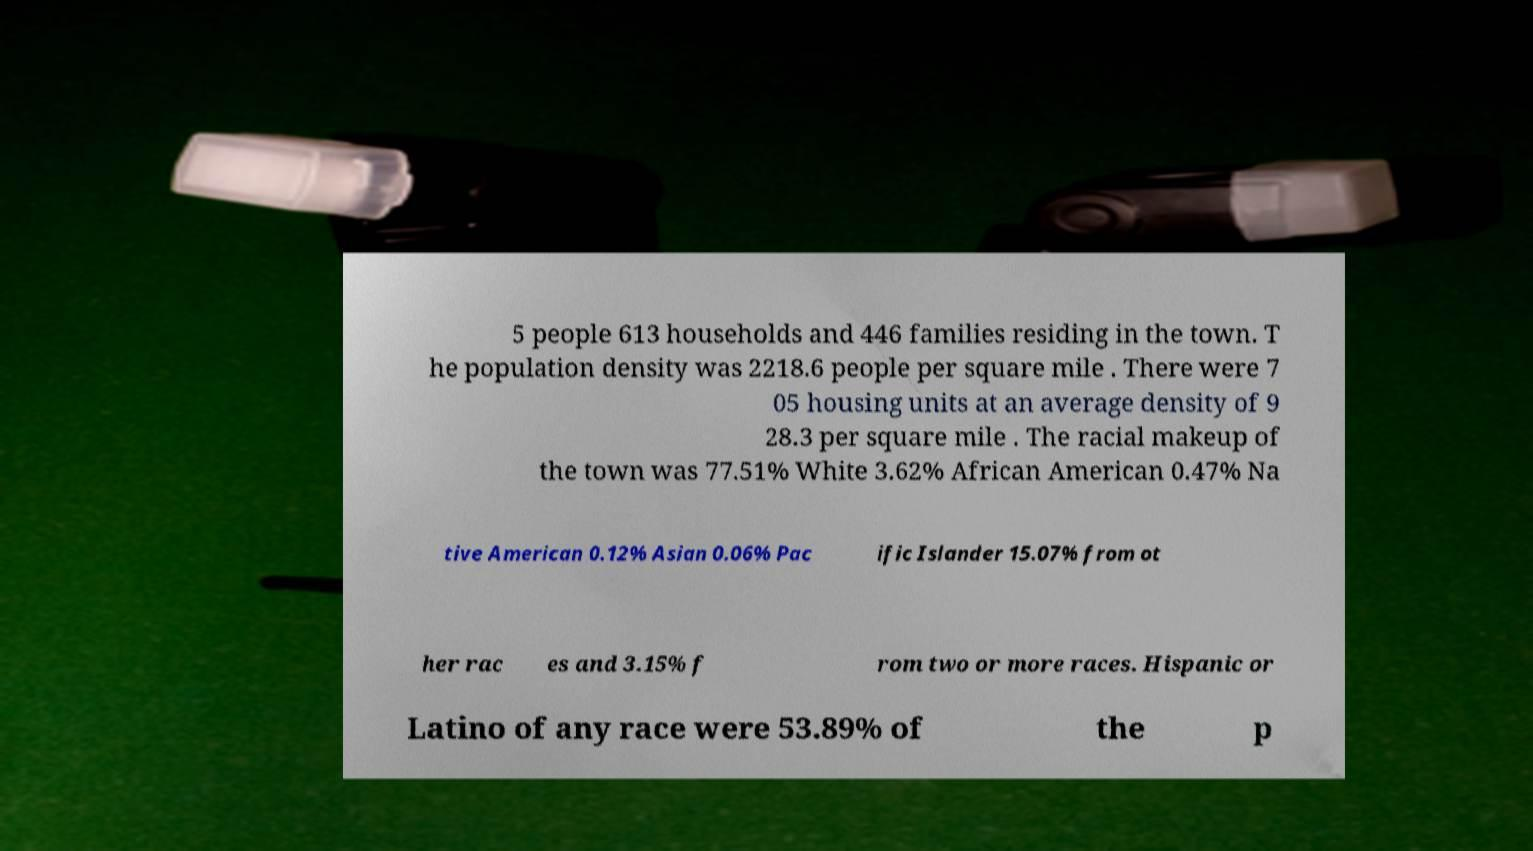Could you extract and type out the text from this image? 5 people 613 households and 446 families residing in the town. T he population density was 2218.6 people per square mile . There were 7 05 housing units at an average density of 9 28.3 per square mile . The racial makeup of the town was 77.51% White 3.62% African American 0.47% Na tive American 0.12% Asian 0.06% Pac ific Islander 15.07% from ot her rac es and 3.15% f rom two or more races. Hispanic or Latino of any race were 53.89% of the p 